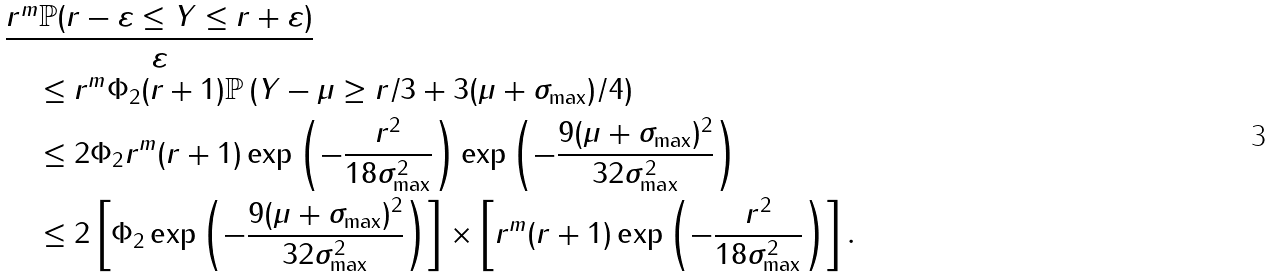Convert formula to latex. <formula><loc_0><loc_0><loc_500><loc_500>& \frac { r ^ { m } \mathbb { P } ( r - \varepsilon \leq \| Y \| \leq r + \varepsilon ) } { \varepsilon } \\ & \quad \leq r ^ { m } \Phi _ { 2 } ( r + 1 ) \mathbb { P } \left ( \| Y \| - \mu \geq r / 3 + 3 ( \mu + \sigma _ { \max } ) / 4 \right ) \\ & \quad \leq 2 \Phi _ { 2 } r ^ { m } ( r + 1 ) \exp \left ( - \frac { r ^ { 2 } } { 1 8 \sigma _ { \max } ^ { 2 } } \right ) \exp \left ( - \frac { 9 ( \mu + \sigma _ { \max } ) ^ { 2 } } { 3 2 \sigma _ { \max } ^ { 2 } } \right ) \\ & \quad \leq 2 \left [ \Phi _ { 2 } \exp \left ( - \frac { 9 ( \mu + \sigma _ { \max } ) ^ { 2 } } { 3 2 \sigma _ { \max } ^ { 2 } } \right ) \right ] \times \left [ r ^ { m } ( r + 1 ) \exp \left ( - \frac { r ^ { 2 } } { 1 8 \sigma _ { \max } ^ { 2 } } \right ) \right ] .</formula> 